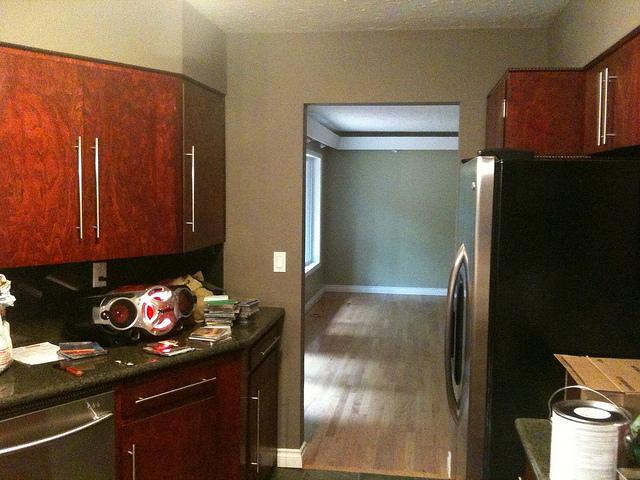Which room is this picture taken from?
Short answer required. Kitchen. IS the back room crowded?
Concise answer only. No. What is the material of the floor?
Answer briefly. Wood. 